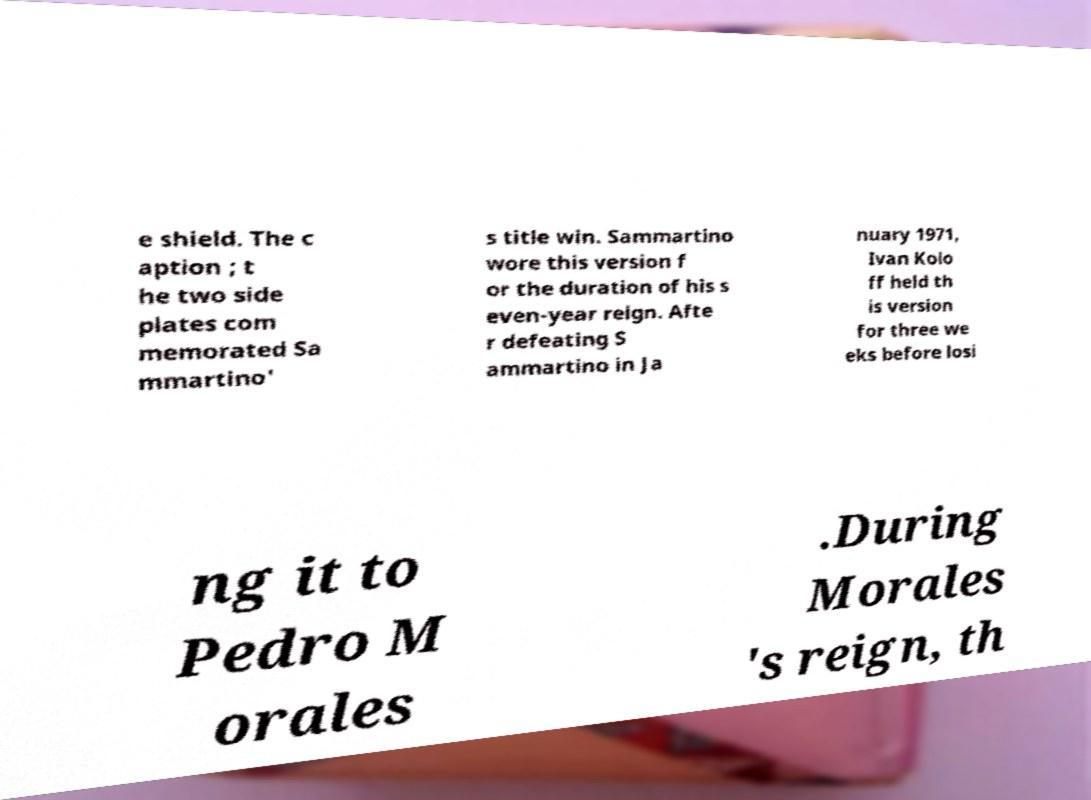Can you read and provide the text displayed in the image?This photo seems to have some interesting text. Can you extract and type it out for me? e shield. The c aption ; t he two side plates com memorated Sa mmartino' s title win. Sammartino wore this version f or the duration of his s even-year reign. Afte r defeating S ammartino in Ja nuary 1971, Ivan Kolo ff held th is version for three we eks before losi ng it to Pedro M orales .During Morales 's reign, th 